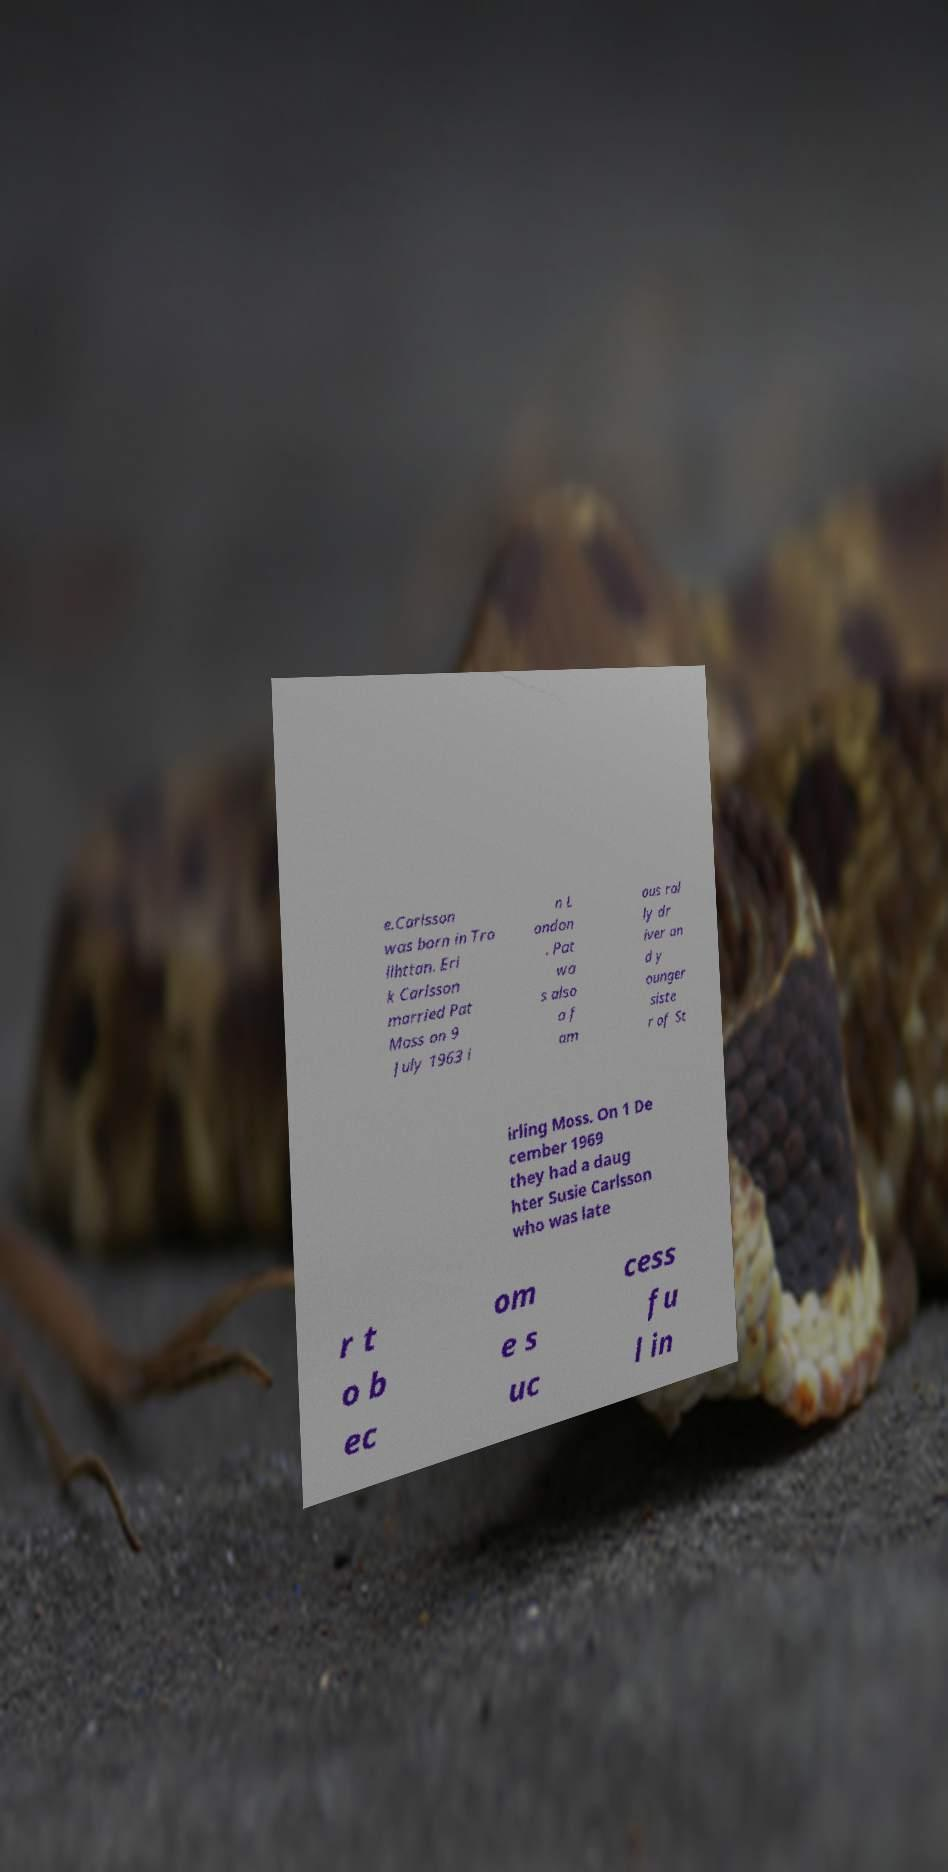Can you accurately transcribe the text from the provided image for me? e.Carlsson was born in Tro llhttan. Eri k Carlsson married Pat Moss on 9 July 1963 i n L ondon . Pat wa s also a f am ous ral ly dr iver an d y ounger siste r of St irling Moss. On 1 De cember 1969 they had a daug hter Susie Carlsson who was late r t o b ec om e s uc cess fu l in 